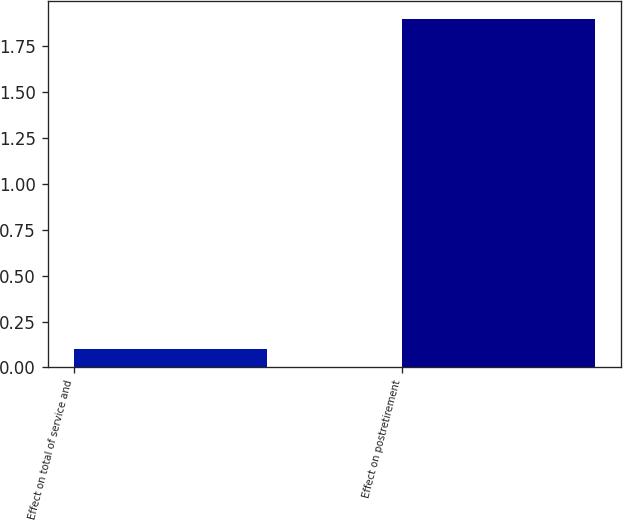<chart> <loc_0><loc_0><loc_500><loc_500><bar_chart><fcel>Effect on total of service and<fcel>Effect on postretirement<nl><fcel>0.1<fcel>1.9<nl></chart> 